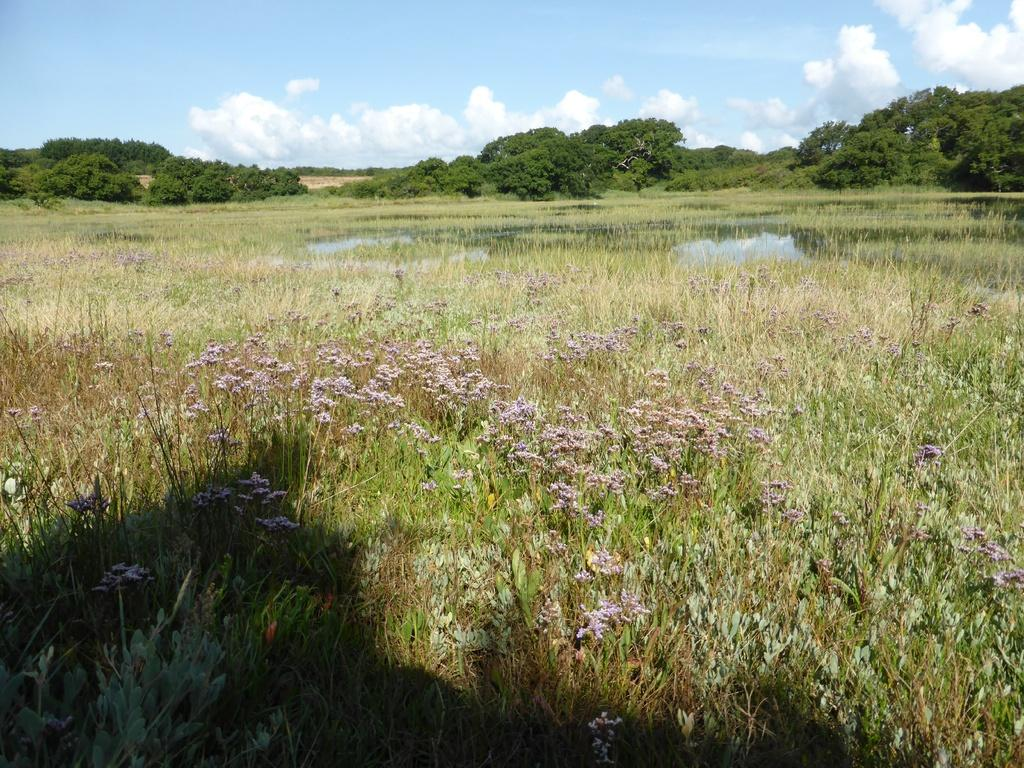What type of vegetation can be seen in the image? There are plants, flowers, grass, and trees visible in the image. What is the source of water in the image? The water is visible in the image, but the source is not specified. What can be seen in the background of the image? The sky is visible in the background of the image, and there are clouds in the sky. What type of jewel can be seen hanging from the tree in the image? There is no jewel hanging from the tree in the image; it features plants, flowers, grass, trees, water, and a sky with clouds. 